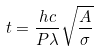Convert formula to latex. <formula><loc_0><loc_0><loc_500><loc_500>t = \frac { h c } { P \lambda } \sqrt { \frac { A } { \sigma } }</formula> 